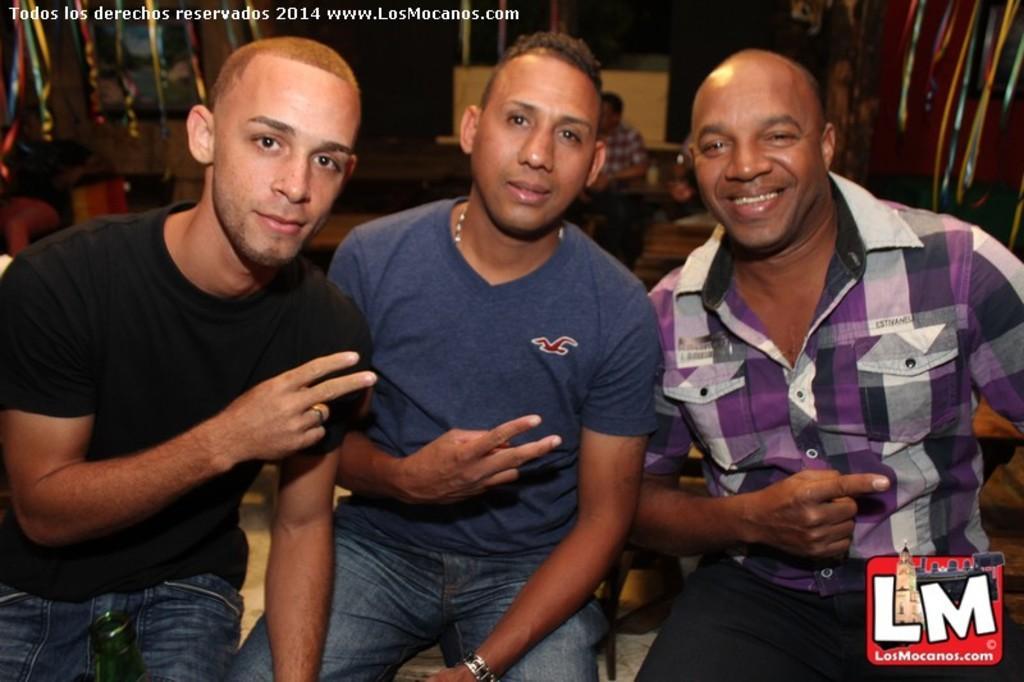Please provide a concise description of this image. In the middle a man is sitting, he wore a t-shirt. On the left side another person is there. She wore black color t-shirt. In the right side this person is smiling. 